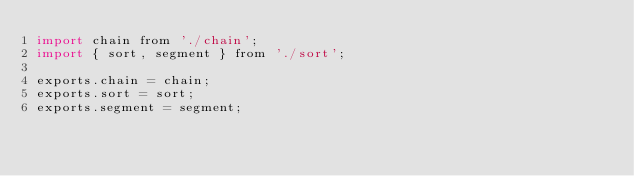<code> <loc_0><loc_0><loc_500><loc_500><_JavaScript_>import chain from './chain';
import { sort, segment } from './sort';

exports.chain = chain;
exports.sort = sort;
exports.segment = segment;
</code> 